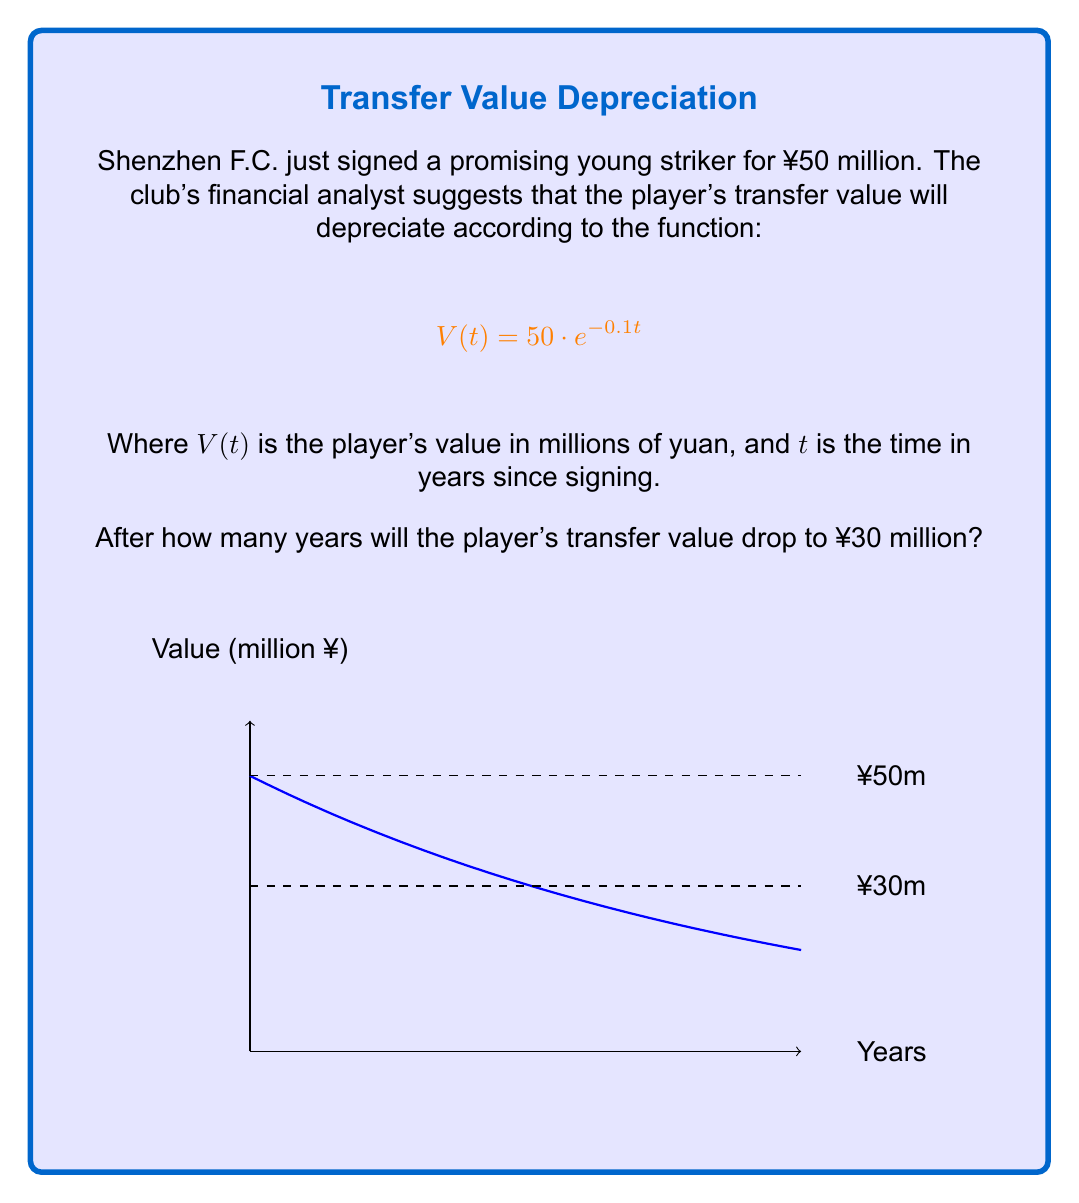Teach me how to tackle this problem. Let's approach this step-by-step:

1) We need to find $t$ when $V(t) = 30$ million yuan.

2) Substitute this into the given equation:
   $$30 = 50 \cdot e^{-0.1t}$$

3) Divide both sides by 50:
   $$\frac{30}{50} = e^{-0.1t}$$

4) Simplify:
   $$0.6 = e^{-0.1t}$$

5) Take the natural logarithm of both sides:
   $$\ln(0.6) = \ln(e^{-0.1t})$$

6) Simplify the right side using the property of logarithms:
   $$\ln(0.6) = -0.1t$$

7) Divide both sides by -0.1:
   $$\frac{\ln(0.6)}{-0.1} = t$$

8) Calculate:
   $$t \approx 5.108$$

Therefore, it will take approximately 5.108 years for the player's value to depreciate to ¥30 million.
Answer: $5.108$ years 